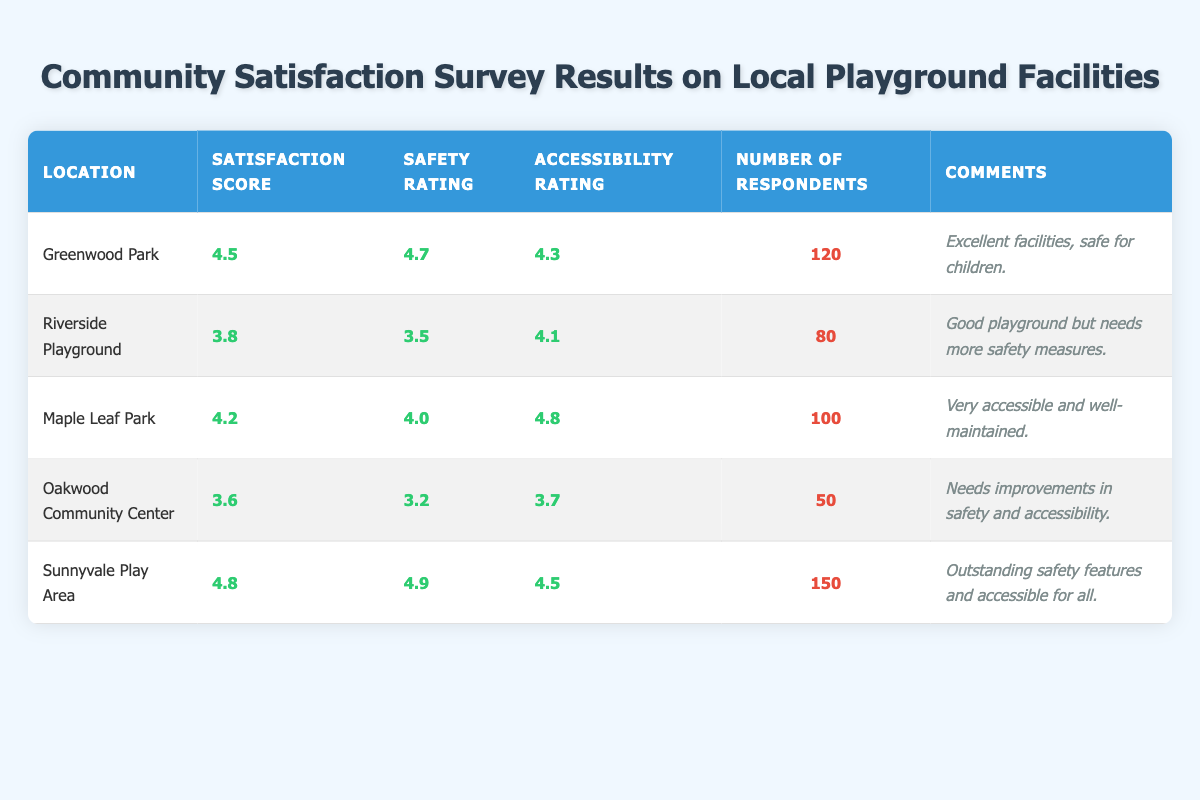What is the satisfaction score for Sunnyvale Play Area? The table lists the satisfaction scores for each playground. For Sunnyvale Play Area, the score is explicitly given as 4.8.
Answer: 4.8 Which playground has the highest safety rating? Comparing the safety ratings in the table, Sunnyvale Play Area has a rating of 4.9, which is higher than all other locations listed.
Answer: Sunnyvale Play Area How many respondents participated in the survey for Oakwood Community Center? The table specifies that 50 respondents participated in the survey for Oakwood Community Center.
Answer: 50 What is the average satisfaction score of all the playgrounds mentioned? To find the average satisfaction score, sum the scores: (4.5 + 3.8 + 4.2 + 3.6 + 4.8) = 20.9. Divide by the number of playgrounds (5): 20.9 / 5 = 4.18.
Answer: 4.18 Is the accessibility rating for Riverside Playground greater than 4? The table shows that the accessibility rating for Riverside Playground is 4.1, which is greater than 4.
Answer: Yes Which playground has the lowest safety rating and what is that rating? The table lists the safety ratings: Oakwood Community Center has the lowest rating at 3.2.
Answer: Oakwood Community Center; 3.2 How many total respondents were surveyed across all playgrounds? To find the total respondents, sum the number of respondents from each playground: 120 + 80 + 100 + 50 + 150 = 600.
Answer: 600 What percentage of respondents rated the safety at Sunnyvale Play Area as excellent? The safety rating for Sunnyvale is 4.9, but a percentage of how many rated it as excellent is not provided in the table, thus we can't determine this from the given data.
Answer: Cannot determine Which playground has both the highest safety and accessibility ratings combined? Looking at the safety and accessibility ratings: Sunnyvale Play Area (4.9 + 4.5 = 9.4), Maple Leaf Park (4.0 + 4.8 = 8.8), and others show lower sums. Sunnyvale has the highest combined ratings.
Answer: Sunnyvale Play Area 